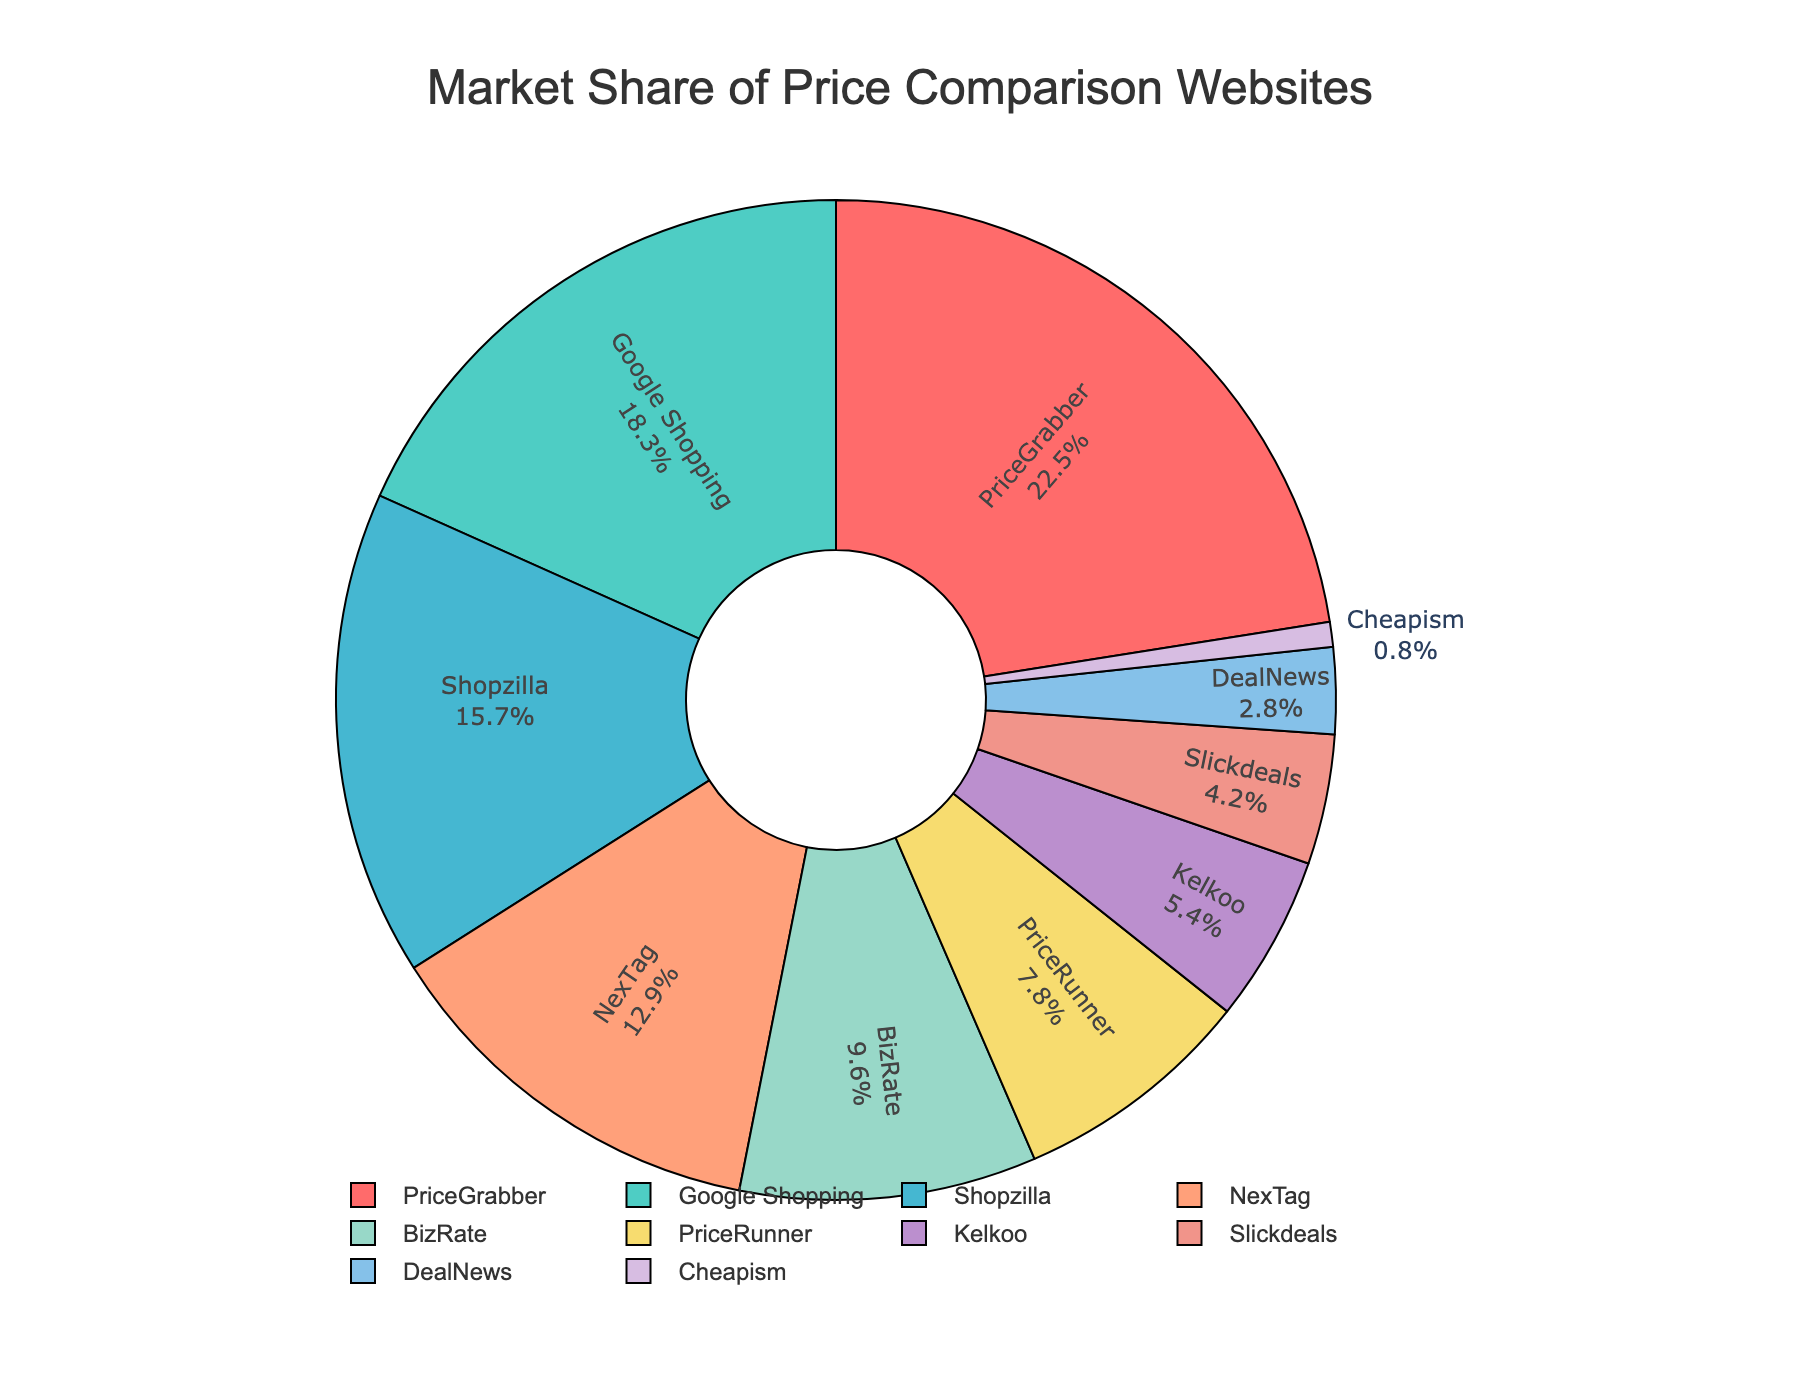what is the market share percent of Google Shopping? Referring to the figure, Google Shopping shows a segment in the pie chart with 18.3% label beside it
Answer: 18.3% Which website has the highest market share? By looking at the pie chart, the segment for PriceGrabber is the largest, indicating it has the highest market share
Answer: PriceGrabber What is the combined market share of BizRate and PriceRunner? The pie chart shows BizRate has a 9.6% share and PriceRunner has a 7.8% share. Adding these, 9.6 + 7.8 = 17.4%
Answer: 17.4% How much more market share does PriceGrabber have compared to DealNews? PriceGrabber has 22.5% and DealNews has 2.8%. Subtracting these, 22.5 - 2.8 = 19.7%
Answer: 19.7% Which two websites have closer market shares: Shopzilla and NexTag, or Kelkoo and Slickdeals? Shopzilla has 15.7% and NexTag 12.9% with a difference of 2.8%. Kelkoo has 5.4% and Slickdeals 4.2% with a difference of 1.2%. The smaller difference indicates Kelkoo and Slickdeals are closer in market share
Answer: Kelkoo and Slickdeals What is the market share difference between the top and bottom websites? PriceGrabber at the top has 22.5% and Cheapism at the bottom has 0.8%. Subtracting these, 22.5 - 0.8 = 21.7%
Answer: 21.7% What is the market share of websites colored in green? The pie chart shows Google Shopping as green with an 18.3% share
Answer: 18.3% Which website holds a market share closest to 10%? Looking at the pie chart, BizRate has a market share of 9.6%, which is closest to 10%
Answer: BizRate If PriceRunner increases its market share by 3%, what would be its new market share? Current market share of PriceRunner is 7.8%. Adding 3%, 7.8 + 3 = 10.8%
Answer: 10.8% Which website has a larger market share, Shopzilla or Google Shopping? Referring to the pie chart, Shopzilla has a 15.7% share and Google Shopping has an 18.3% share. Therefore, Google Shopping has a larger market share
Answer: Google Shopping 